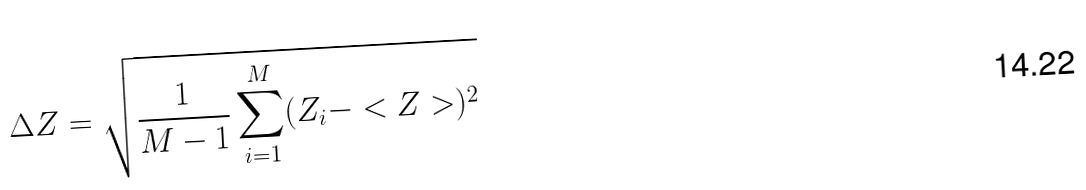Convert formula to latex. <formula><loc_0><loc_0><loc_500><loc_500>\Delta Z = \sqrt { \frac { 1 } { M - 1 } \sum _ { i = 1 } ^ { M } ( Z _ { i } - < Z > ) ^ { 2 } }</formula> 